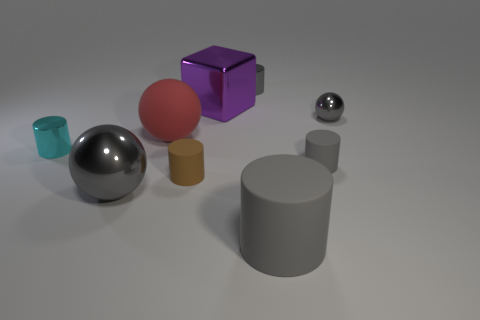Subtract all gray blocks. How many gray cylinders are left? 3 Subtract all cyan cylinders. How many cylinders are left? 4 Subtract all brown cylinders. How many cylinders are left? 4 Subtract all red cylinders. Subtract all yellow spheres. How many cylinders are left? 5 Add 1 small cyan blocks. How many objects exist? 10 Subtract all cylinders. How many objects are left? 4 Add 3 tiny yellow shiny cylinders. How many tiny yellow shiny cylinders exist? 3 Subtract 0 yellow blocks. How many objects are left? 9 Subtract all big cyan spheres. Subtract all big cylinders. How many objects are left? 8 Add 1 tiny gray spheres. How many tiny gray spheres are left? 2 